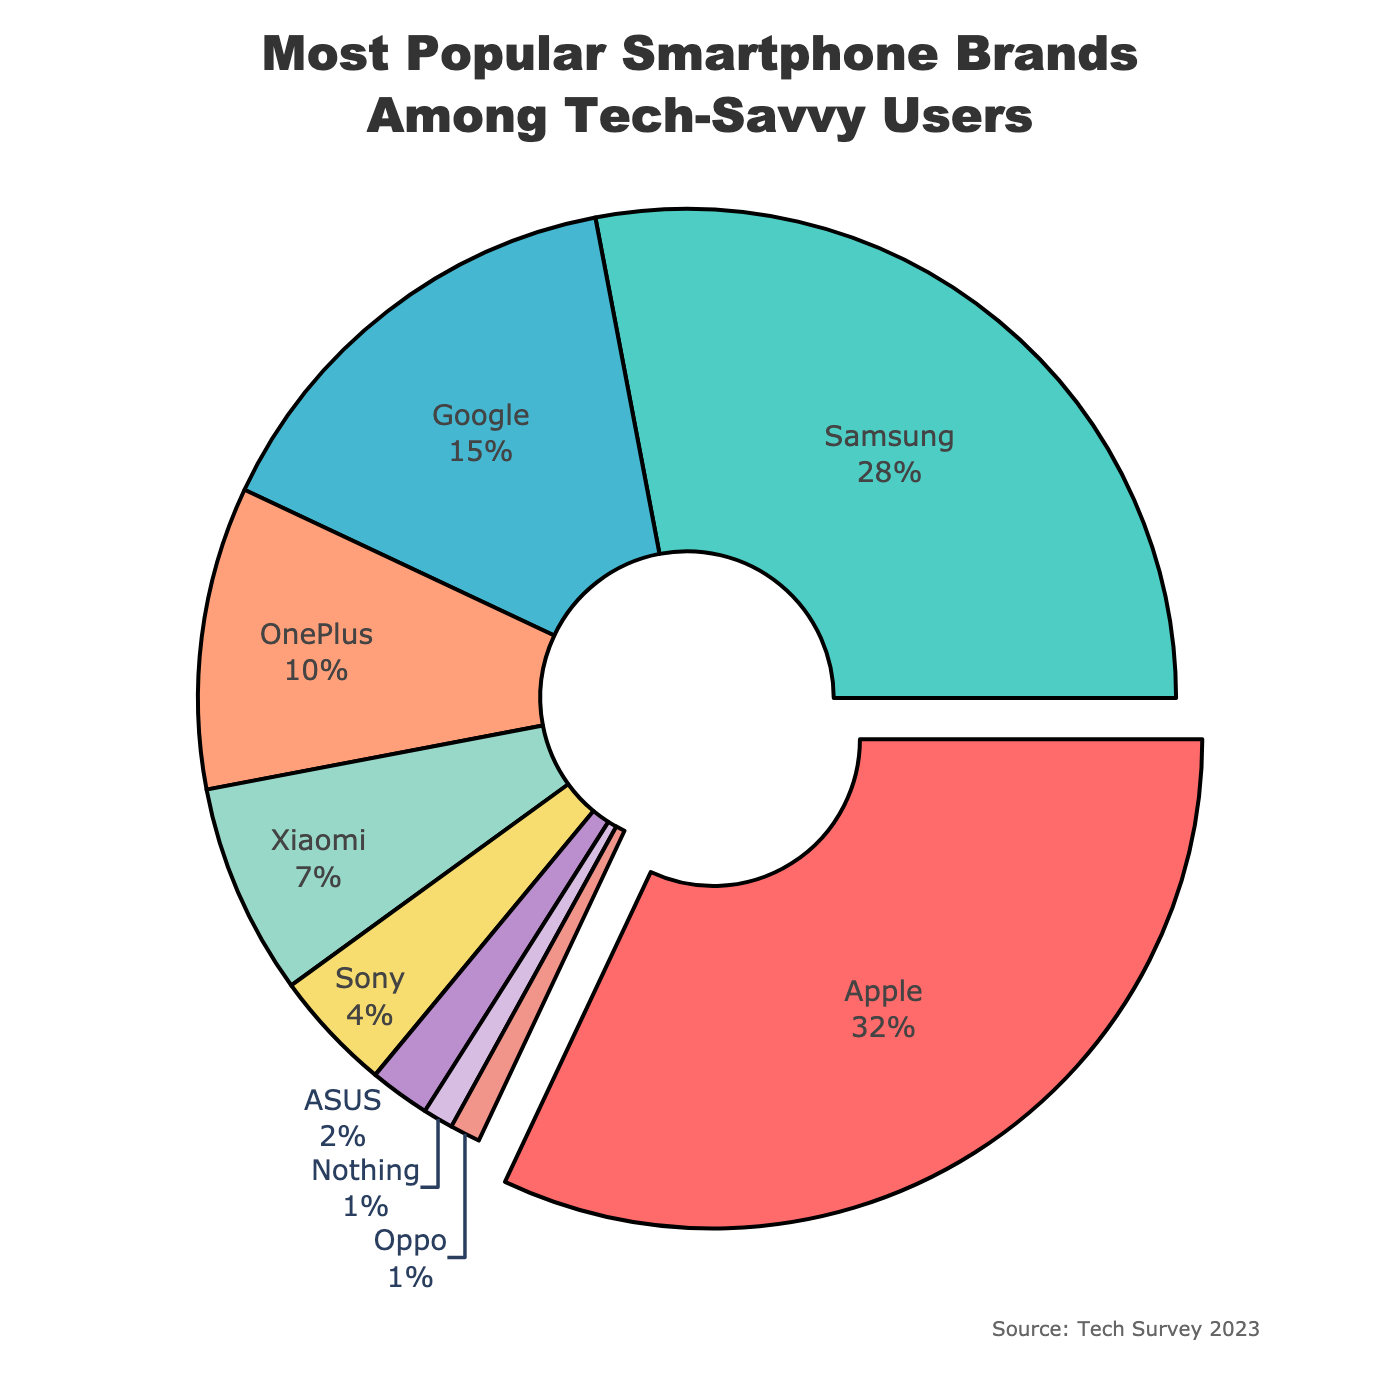What is the most popular smartphone brand among tech-savvy users according to the pie chart? The brand with the largest portion in the pie chart is identified as the most popular. Apple occupies the largest segment in the chart.
Answer: Apple Which smartphone brand has the smallest market share among tech-savvy users? The brand with the smallest slice of the pie chart represents the smallest market share. The smallest slice is labeled "Oppo," tied with "Nothing," but Oppo is the last in the legend.
Answer: Oppo What is the combined market share of Google and OnePlus? Add the percentages for Google and OnePlus. Google has 15% and OnePlus has 10%. The sum is 15% + 10% = 25%.
Answer: 25% How much greater is Apple’s market share compared to Samsung’s? Subtract Samsung's percentage from Apple's percentage. Apple's market share is 32% and Samsung's is 28%. The difference is 32% - 28% = 4%.
Answer: 4% What percentage of tech-savvy users prefer brands other than Apple and Samsung? Subtract the sum of Apple and Samsung's market shares from 100%. Apple has 32% and Samsung has 28%. The sum is 32% + 28% = 60%. Therefore, the percentage for other brands is 100% - 60% = 40%.
Answer: 40% Which smartphone brands have a market share greater than 10%? Identify the brands with percentages larger than 10%. Apple (32%), Samsung (28%), and Google (15%) meet this criterion.
Answer: Apple, Samsung, Google Are there more tech-savvy users preferring OnePlus or Xiaomi? Compare the percentages for OnePlus and Xiaomi. OnePlus has 10% and Xiaomi has 7%. OnePlus has a higher percentage.
Answer: OnePlus What color represents Samsung in the pie chart? The second-largest segment in the pie chart, which represents Samsung, is colored in a turquoise-like hue.
Answer: Turquoise What is the combined percentage for the least popular three brands? Sum the percentages for the three brands with the smallest slices. ASUS has 2%, Nothing has 1%, and Oppo has 1%. The sum is 2% + 1% + 1% = 4%.
Answer: 4% Which portion of the pie chart is pulled away from the center? The pie chart segment that is pulled away from the center represents the brand with the most significant market share. The only pulled-out segment is for Apple.
Answer: Apple 